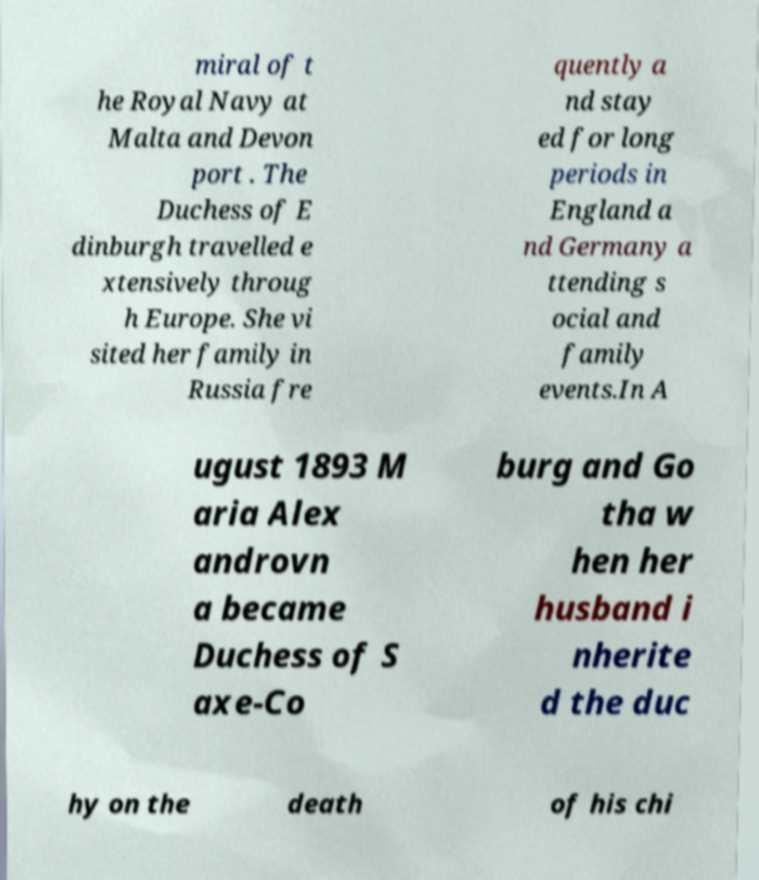For documentation purposes, I need the text within this image transcribed. Could you provide that? miral of t he Royal Navy at Malta and Devon port . The Duchess of E dinburgh travelled e xtensively throug h Europe. She vi sited her family in Russia fre quently a nd stay ed for long periods in England a nd Germany a ttending s ocial and family events.In A ugust 1893 M aria Alex androvn a became Duchess of S axe-Co burg and Go tha w hen her husband i nherite d the duc hy on the death of his chi 